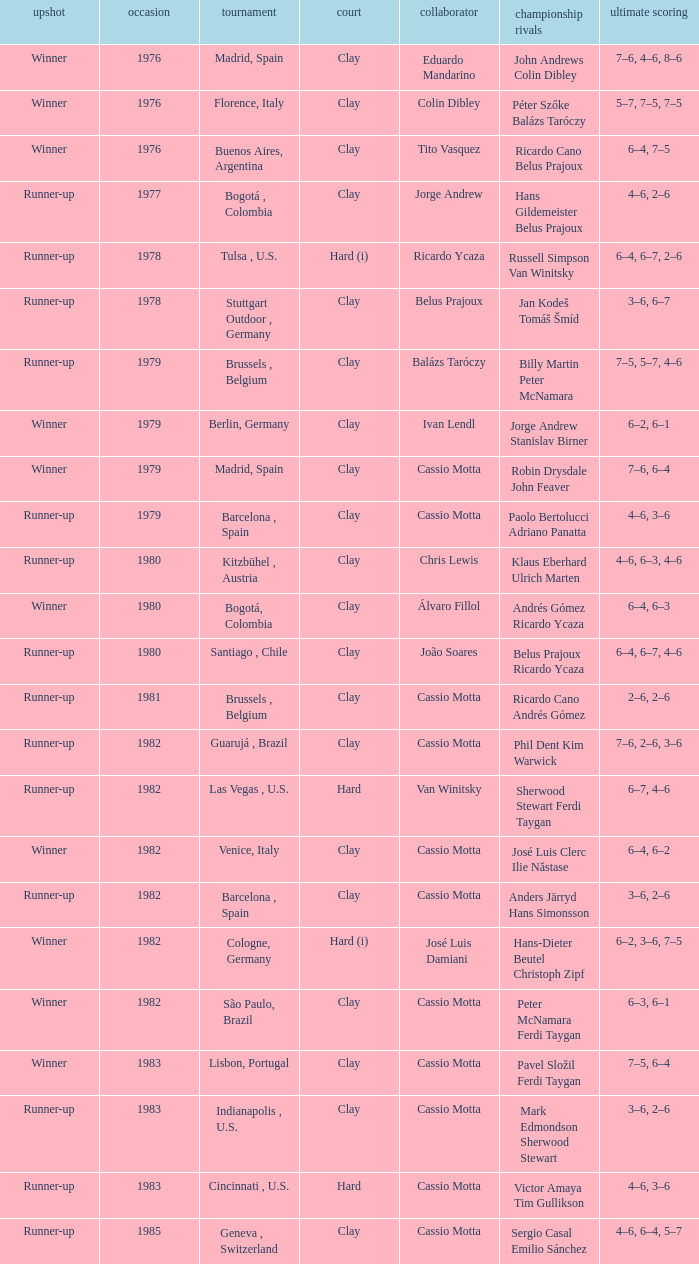What was the surface in 1981? Clay. 